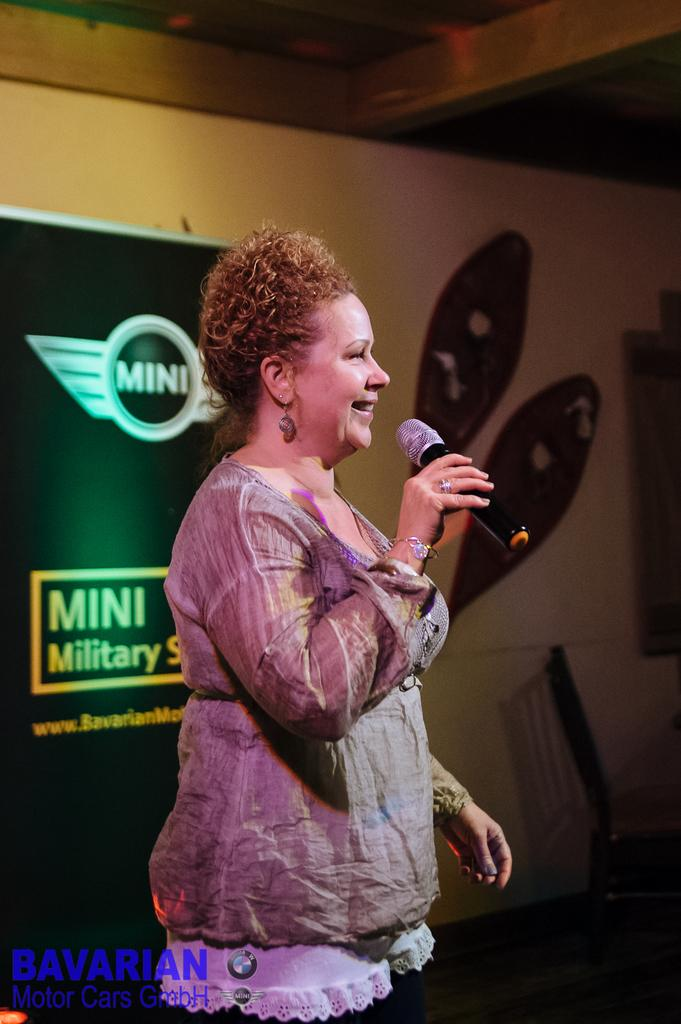Who is the main subject in the image? There is a woman in the image. What is the woman holding in the image? The woman is holding a mic. What is the woman's facial expression in the image? The woman is smiling. What can be seen in the background of the image? There is a poster and a wall in the background of the image. What type of cherry is the woman eating in the image? There is no cherry present in the image, and the woman is not eating anything. What boundary is the woman standing near in the image? There is no boundary visible in the image; it only features the woman, the mic, the poster, and the wall. 